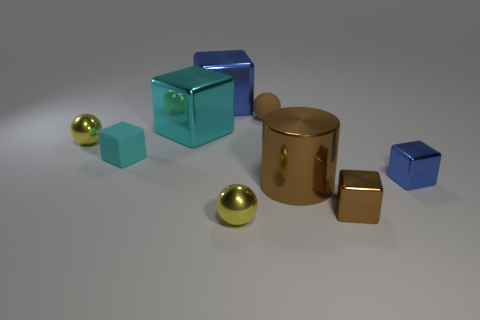There is a metallic block that is the same color as the cylinder; what is its size?
Keep it short and to the point. Small. What is the color of the big shiny object that is behind the brown ball?
Keep it short and to the point. Blue. Is the color of the tiny rubber sphere the same as the cube left of the big cyan shiny cube?
Offer a terse response. No. Are there fewer tiny red metallic cylinders than tiny metal spheres?
Provide a succinct answer. Yes. Does the big cube that is in front of the big blue block have the same color as the big cylinder?
Your response must be concise. No. What number of purple cylinders are the same size as the brown matte ball?
Provide a short and direct response. 0. Is there a shiny object of the same color as the large cylinder?
Offer a very short reply. Yes. Do the small blue thing and the brown block have the same material?
Offer a very short reply. Yes. What number of green shiny things are the same shape as the small blue shiny thing?
Offer a very short reply. 0. The big brown thing that is made of the same material as the brown block is what shape?
Provide a short and direct response. Cylinder. 